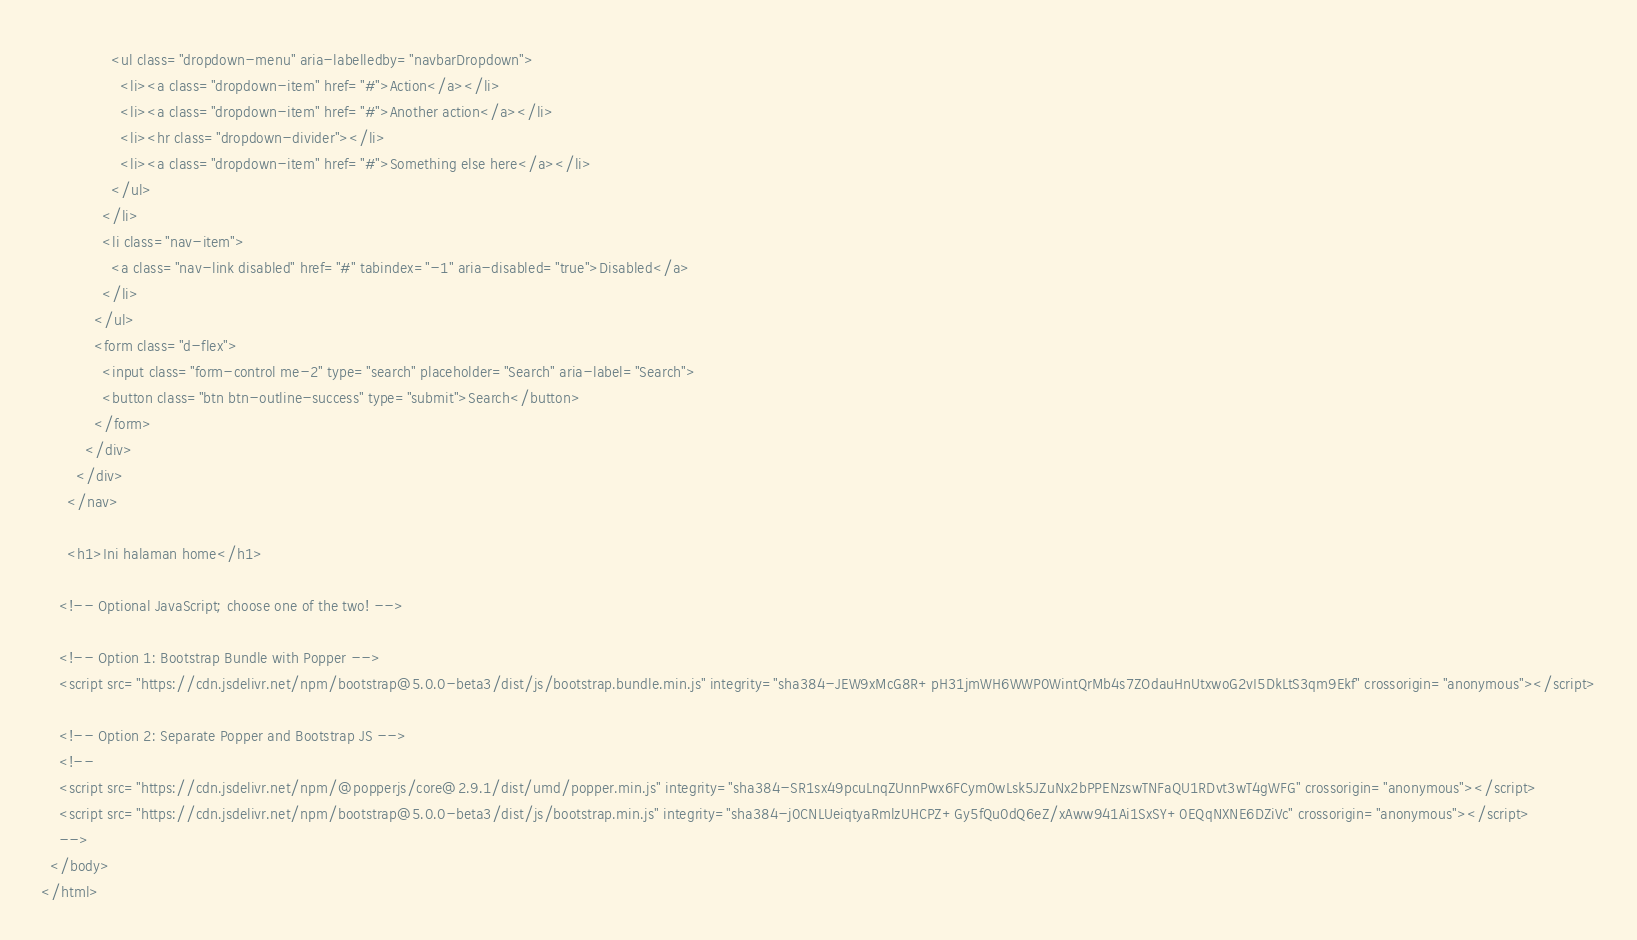<code> <loc_0><loc_0><loc_500><loc_500><_PHP_>                <ul class="dropdown-menu" aria-labelledby="navbarDropdown">
                  <li><a class="dropdown-item" href="#">Action</a></li>
                  <li><a class="dropdown-item" href="#">Another action</a></li>
                  <li><hr class="dropdown-divider"></li>
                  <li><a class="dropdown-item" href="#">Something else here</a></li>
                </ul>
              </li>
              <li class="nav-item">
                <a class="nav-link disabled" href="#" tabindex="-1" aria-disabled="true">Disabled</a>
              </li>
            </ul>
            <form class="d-flex">
              <input class="form-control me-2" type="search" placeholder="Search" aria-label="Search">
              <button class="btn btn-outline-success" type="submit">Search</button>
            </form>
          </div>
        </div>
      </nav>

      <h1>Ini halaman home</h1>

    <!-- Optional JavaScript; choose one of the two! -->

    <!-- Option 1: Bootstrap Bundle with Popper -->
    <script src="https://cdn.jsdelivr.net/npm/bootstrap@5.0.0-beta3/dist/js/bootstrap.bundle.min.js" integrity="sha384-JEW9xMcG8R+pH31jmWH6WWP0WintQrMb4s7ZOdauHnUtxwoG2vI5DkLtS3qm9Ekf" crossorigin="anonymous"></script>

    <!-- Option 2: Separate Popper and Bootstrap JS -->
    <!--
    <script src="https://cdn.jsdelivr.net/npm/@popperjs/core@2.9.1/dist/umd/popper.min.js" integrity="sha384-SR1sx49pcuLnqZUnnPwx6FCym0wLsk5JZuNx2bPPENzswTNFaQU1RDvt3wT4gWFG" crossorigin="anonymous"></script>
    <script src="https://cdn.jsdelivr.net/npm/bootstrap@5.0.0-beta3/dist/js/bootstrap.min.js" integrity="sha384-j0CNLUeiqtyaRmlzUHCPZ+Gy5fQu0dQ6eZ/xAww941Ai1SxSY+0EQqNXNE6DZiVc" crossorigin="anonymous"></script>
    -->
  </body>
</html></code> 